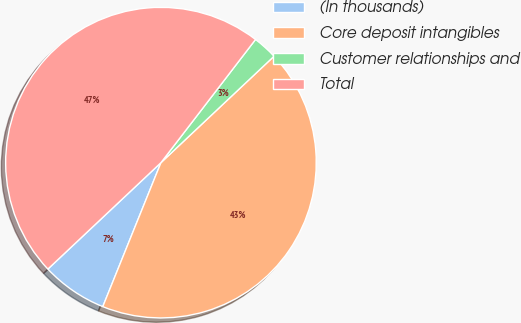Convert chart. <chart><loc_0><loc_0><loc_500><loc_500><pie_chart><fcel>(In thousands)<fcel>Core deposit intangibles<fcel>Customer relationships and<fcel>Total<nl><fcel>6.87%<fcel>43.13%<fcel>2.56%<fcel>47.44%<nl></chart> 